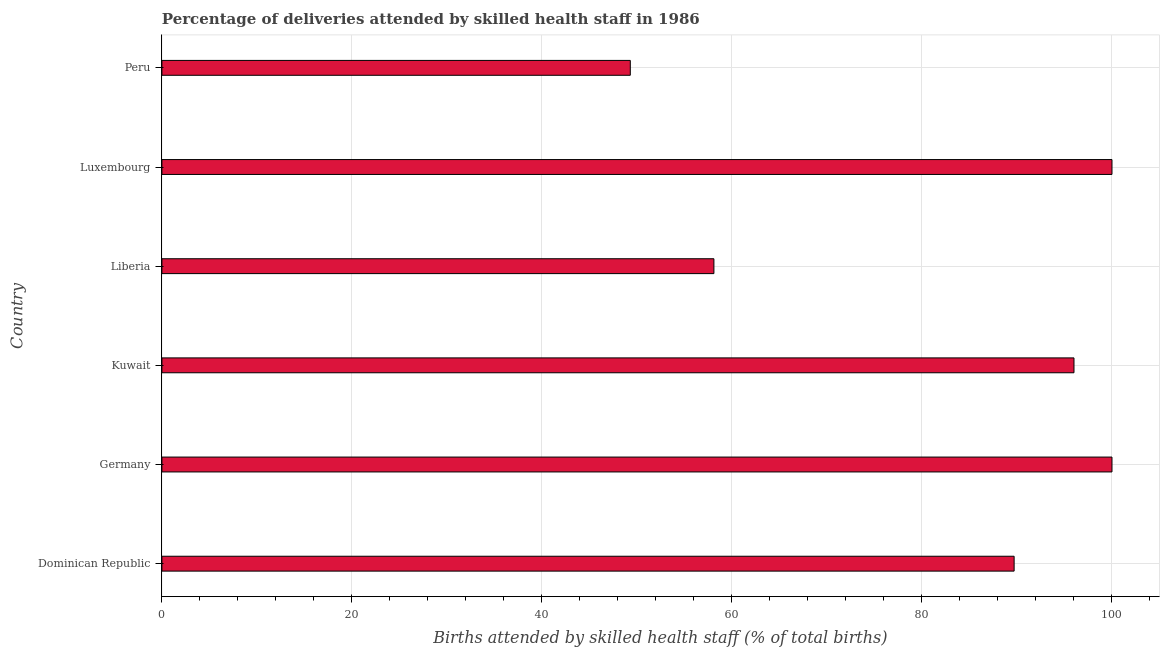What is the title of the graph?
Your answer should be compact. Percentage of deliveries attended by skilled health staff in 1986. What is the label or title of the X-axis?
Provide a short and direct response. Births attended by skilled health staff (% of total births). What is the label or title of the Y-axis?
Provide a succinct answer. Country. What is the number of births attended by skilled health staff in Liberia?
Provide a succinct answer. 58.1. Across all countries, what is the maximum number of births attended by skilled health staff?
Provide a succinct answer. 100. Across all countries, what is the minimum number of births attended by skilled health staff?
Give a very brief answer. 49.3. What is the sum of the number of births attended by skilled health staff?
Offer a very short reply. 493.1. What is the average number of births attended by skilled health staff per country?
Your answer should be compact. 82.18. What is the median number of births attended by skilled health staff?
Your answer should be very brief. 92.85. What is the ratio of the number of births attended by skilled health staff in Kuwait to that in Peru?
Keep it short and to the point. 1.95. What is the difference between the highest and the second highest number of births attended by skilled health staff?
Provide a short and direct response. 0. Is the sum of the number of births attended by skilled health staff in Liberia and Peru greater than the maximum number of births attended by skilled health staff across all countries?
Your answer should be very brief. Yes. What is the difference between the highest and the lowest number of births attended by skilled health staff?
Give a very brief answer. 50.7. Are all the bars in the graph horizontal?
Offer a terse response. Yes. How many countries are there in the graph?
Give a very brief answer. 6. What is the difference between two consecutive major ticks on the X-axis?
Provide a succinct answer. 20. What is the Births attended by skilled health staff (% of total births) of Dominican Republic?
Make the answer very short. 89.7. What is the Births attended by skilled health staff (% of total births) of Kuwait?
Your answer should be very brief. 96. What is the Births attended by skilled health staff (% of total births) in Liberia?
Your answer should be very brief. 58.1. What is the Births attended by skilled health staff (% of total births) of Peru?
Your response must be concise. 49.3. What is the difference between the Births attended by skilled health staff (% of total births) in Dominican Republic and Germany?
Give a very brief answer. -10.3. What is the difference between the Births attended by skilled health staff (% of total births) in Dominican Republic and Kuwait?
Provide a short and direct response. -6.3. What is the difference between the Births attended by skilled health staff (% of total births) in Dominican Republic and Liberia?
Your answer should be very brief. 31.6. What is the difference between the Births attended by skilled health staff (% of total births) in Dominican Republic and Peru?
Offer a terse response. 40.4. What is the difference between the Births attended by skilled health staff (% of total births) in Germany and Kuwait?
Your answer should be compact. 4. What is the difference between the Births attended by skilled health staff (% of total births) in Germany and Liberia?
Offer a terse response. 41.9. What is the difference between the Births attended by skilled health staff (% of total births) in Germany and Peru?
Your answer should be very brief. 50.7. What is the difference between the Births attended by skilled health staff (% of total births) in Kuwait and Liberia?
Make the answer very short. 37.9. What is the difference between the Births attended by skilled health staff (% of total births) in Kuwait and Peru?
Your response must be concise. 46.7. What is the difference between the Births attended by skilled health staff (% of total births) in Liberia and Luxembourg?
Provide a short and direct response. -41.9. What is the difference between the Births attended by skilled health staff (% of total births) in Luxembourg and Peru?
Your answer should be compact. 50.7. What is the ratio of the Births attended by skilled health staff (% of total births) in Dominican Republic to that in Germany?
Provide a succinct answer. 0.9. What is the ratio of the Births attended by skilled health staff (% of total births) in Dominican Republic to that in Kuwait?
Your answer should be very brief. 0.93. What is the ratio of the Births attended by skilled health staff (% of total births) in Dominican Republic to that in Liberia?
Offer a very short reply. 1.54. What is the ratio of the Births attended by skilled health staff (% of total births) in Dominican Republic to that in Luxembourg?
Your answer should be very brief. 0.9. What is the ratio of the Births attended by skilled health staff (% of total births) in Dominican Republic to that in Peru?
Offer a very short reply. 1.82. What is the ratio of the Births attended by skilled health staff (% of total births) in Germany to that in Kuwait?
Give a very brief answer. 1.04. What is the ratio of the Births attended by skilled health staff (% of total births) in Germany to that in Liberia?
Provide a succinct answer. 1.72. What is the ratio of the Births attended by skilled health staff (% of total births) in Germany to that in Peru?
Your answer should be very brief. 2.03. What is the ratio of the Births attended by skilled health staff (% of total births) in Kuwait to that in Liberia?
Your answer should be compact. 1.65. What is the ratio of the Births attended by skilled health staff (% of total births) in Kuwait to that in Peru?
Your answer should be compact. 1.95. What is the ratio of the Births attended by skilled health staff (% of total births) in Liberia to that in Luxembourg?
Your answer should be very brief. 0.58. What is the ratio of the Births attended by skilled health staff (% of total births) in Liberia to that in Peru?
Ensure brevity in your answer.  1.18. What is the ratio of the Births attended by skilled health staff (% of total births) in Luxembourg to that in Peru?
Offer a terse response. 2.03. 